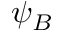<formula> <loc_0><loc_0><loc_500><loc_500>\psi _ { B }</formula> 